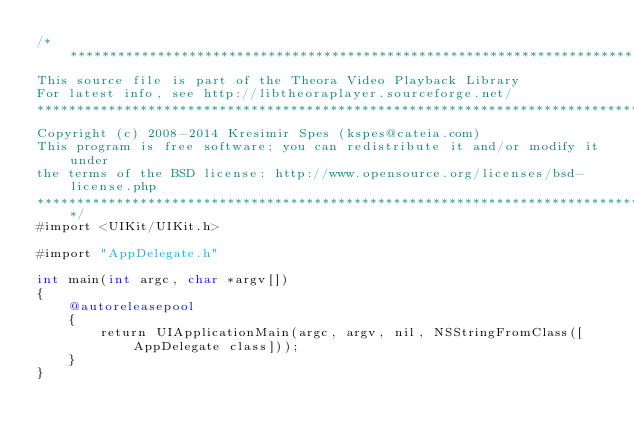<code> <loc_0><loc_0><loc_500><loc_500><_ObjectiveC_>/************************************************************************************
This source file is part of the Theora Video Playback Library
For latest info, see http://libtheoraplayer.sourceforge.net/
*************************************************************************************
Copyright (c) 2008-2014 Kresimir Spes (kspes@cateia.com)
This program is free software; you can redistribute it and/or modify it under
the terms of the BSD license: http://www.opensource.org/licenses/bsd-license.php
*************************************************************************************/
#import <UIKit/UIKit.h>

#import "AppDelegate.h"

int main(int argc, char *argv[])
{
	@autoreleasepool
	{
	    return UIApplicationMain(argc, argv, nil, NSStringFromClass([AppDelegate class]));
	}
}
</code> 